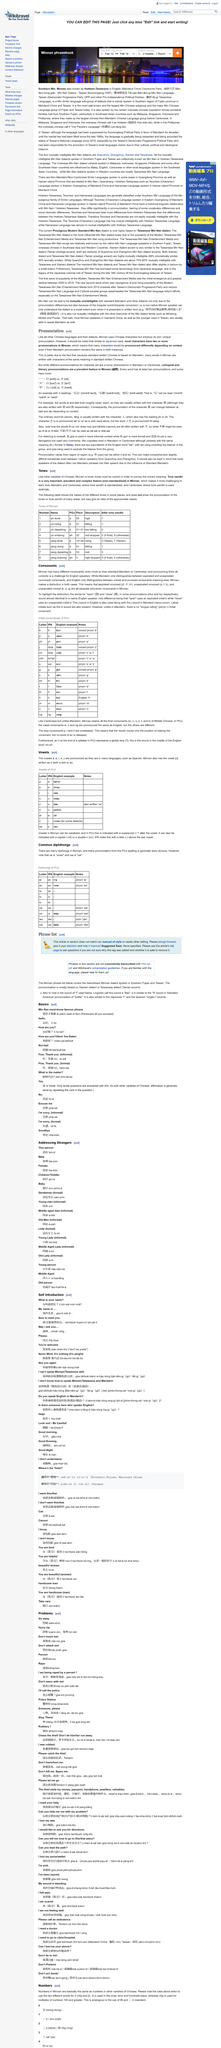Outline some significant characteristics in this image. The Southern Min, Minnan language is a sub-group of Min Sinitic dialects primarily used in the southern region of Fujan province in mainland China and Taiwan. The overseas Chinese people in the Philippines refer to their native Southern Min, Minnan language as "Our People's Language. Southern Min, also known as Minnan or Hokkien-Taiwanese, is a language spoken in Southern China and Taiwan, known for its distinct accent and grammar. 